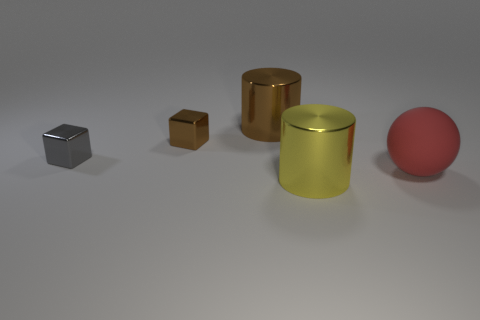There is another block that is the same size as the gray block; what material is it?
Provide a short and direct response. Metal. What number of big purple matte spheres are there?
Give a very brief answer. 0. How big is the cylinder that is in front of the big matte object?
Your answer should be compact. Large. Are there an equal number of large things that are to the right of the yellow metal cylinder and balls?
Your answer should be compact. Yes. Is there a large object of the same shape as the tiny brown object?
Ensure brevity in your answer.  No. What is the shape of the shiny thing that is both in front of the small brown cube and on the left side of the yellow thing?
Provide a short and direct response. Cube. Is the material of the large ball the same as the cylinder that is behind the big yellow shiny object?
Make the answer very short. No. There is a large brown metal object; are there any large metal things to the right of it?
Your answer should be very brief. Yes. How many objects are either big cyan matte things or large cylinders that are in front of the gray object?
Make the answer very short. 1. What color is the cylinder left of the shiny cylinder that is in front of the gray metallic block?
Provide a short and direct response. Brown. 